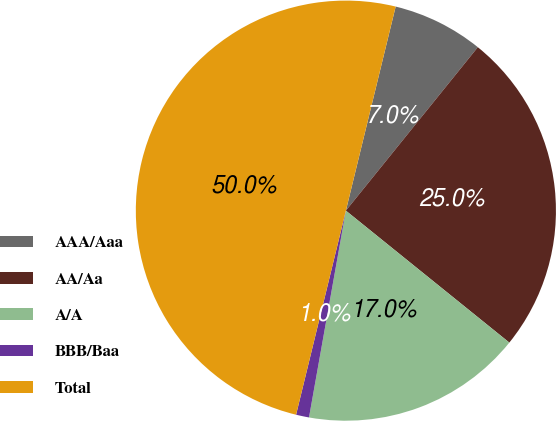Convert chart to OTSL. <chart><loc_0><loc_0><loc_500><loc_500><pie_chart><fcel>AAA/Aaa<fcel>AA/Aa<fcel>A/A<fcel>BBB/Baa<fcel>Total<nl><fcel>7.0%<fcel>25.0%<fcel>17.0%<fcel>1.0%<fcel>50.0%<nl></chart> 